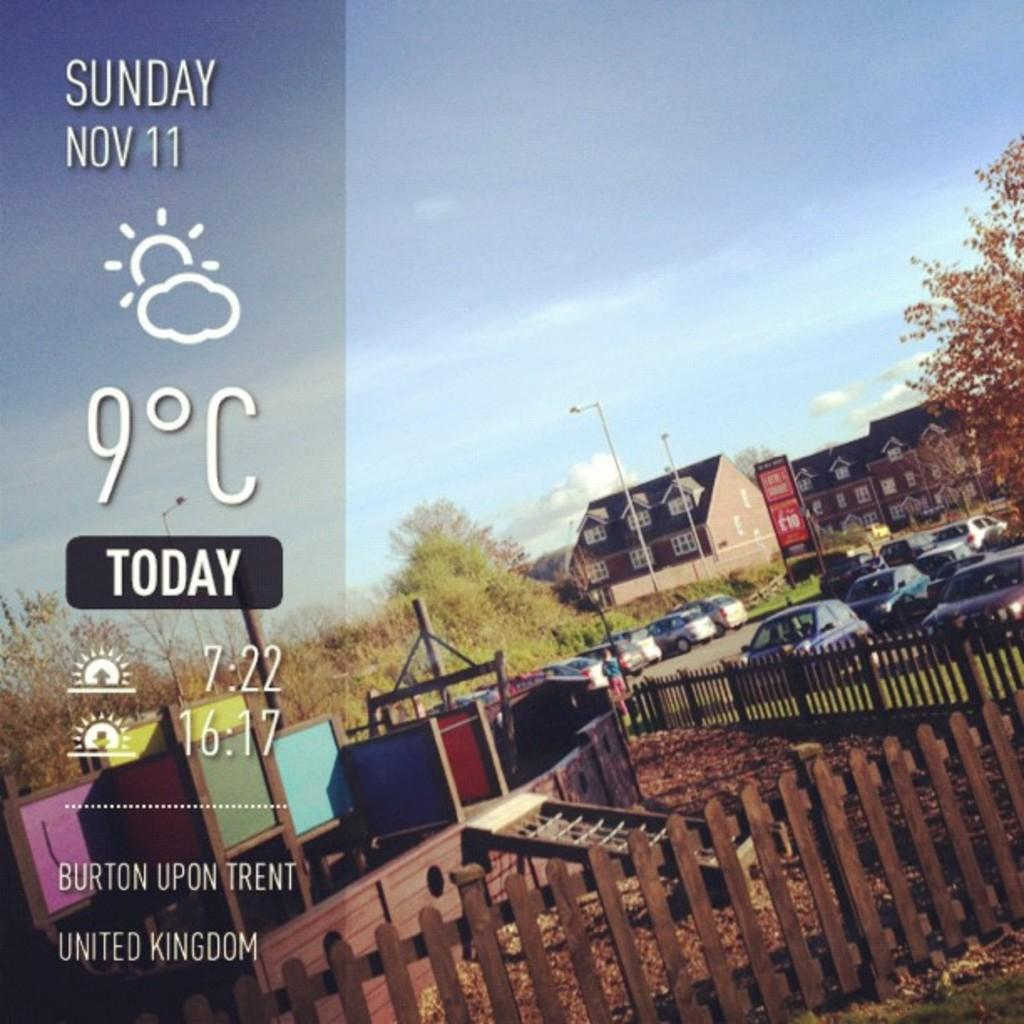<image>
Provide a brief description of the given image. a screen shot says Sunday Nov 11 at Burton Upon Trent 